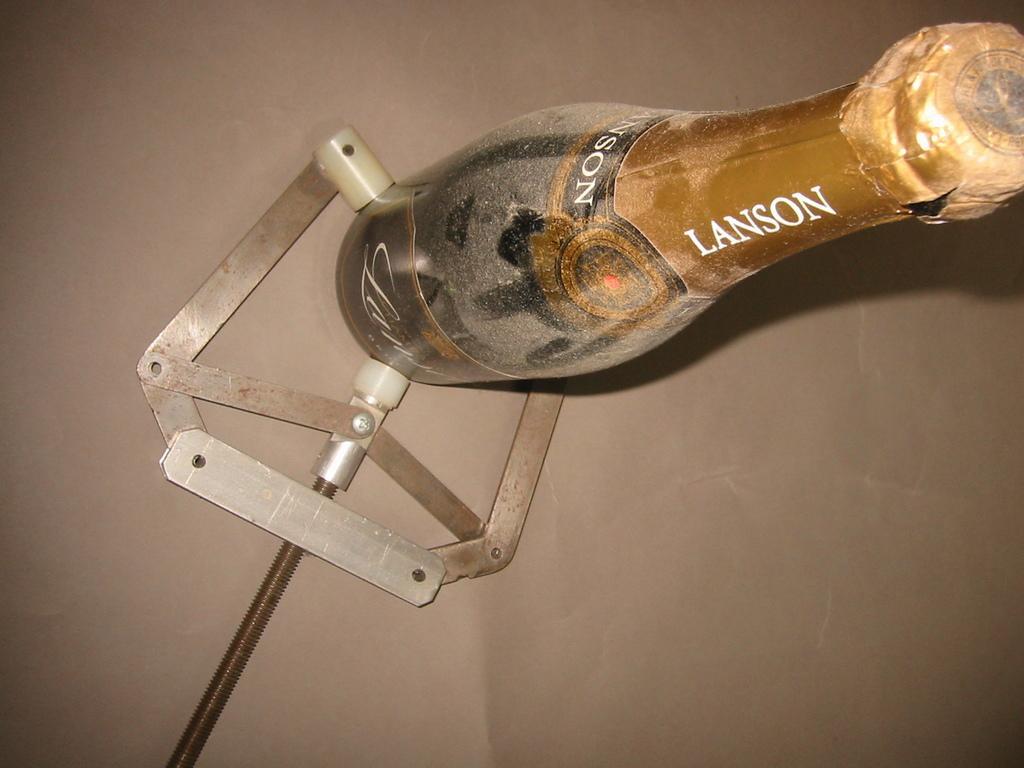How would you summarize this image in a sentence or two? In this image we can see a tool placed on the surface is holding a bottle. 